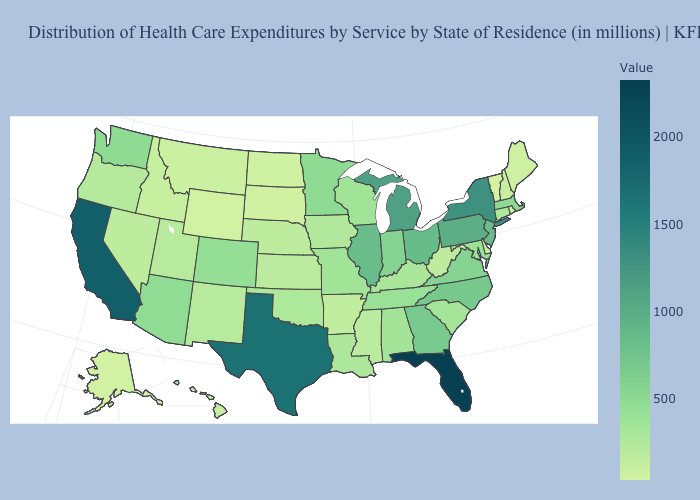Does Florida have the highest value in the USA?
Give a very brief answer. Yes. Which states have the lowest value in the USA?
Quick response, please. Vermont. Does Florida have the highest value in the USA?
Be succinct. Yes. Does Maryland have a lower value than Florida?
Short answer required. Yes. Among the states that border Maine , which have the highest value?
Give a very brief answer. New Hampshire. Is the legend a continuous bar?
Concise answer only. Yes. Does New Mexico have the highest value in the West?
Keep it brief. No. 